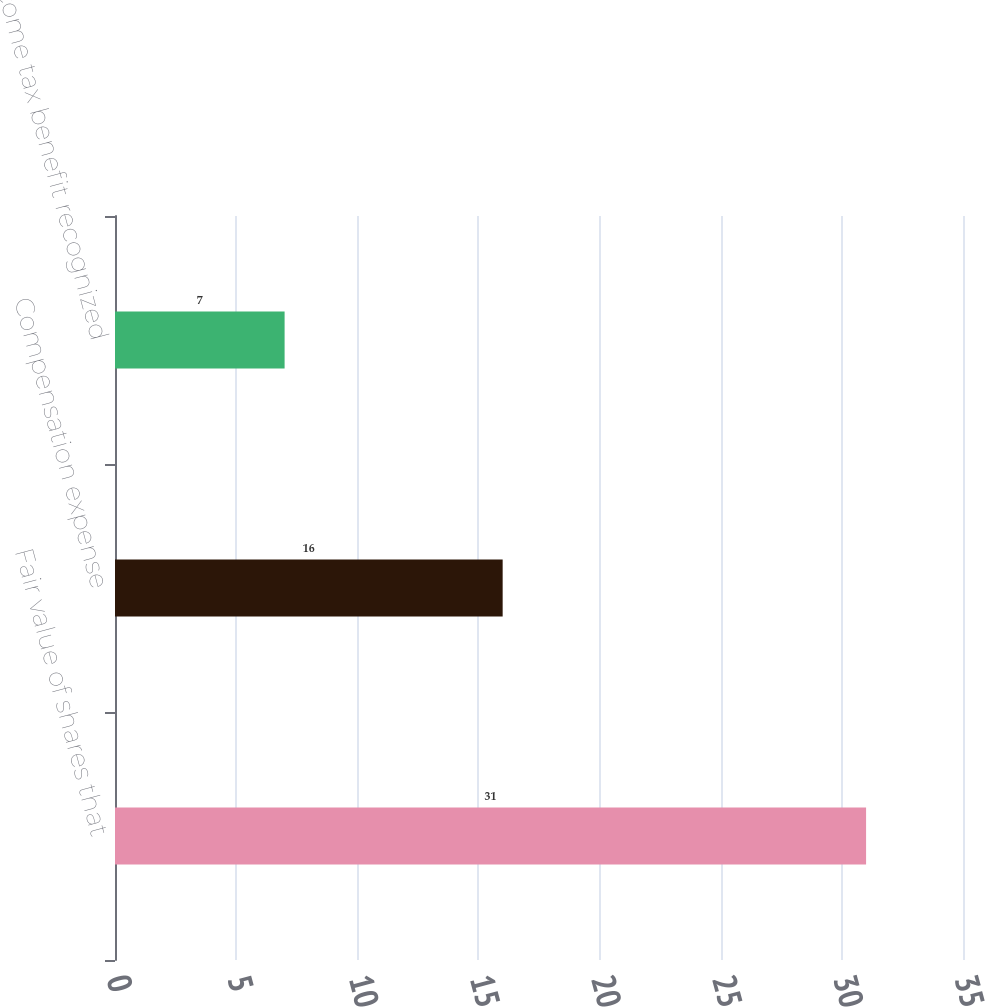<chart> <loc_0><loc_0><loc_500><loc_500><bar_chart><fcel>Fair value of shares that<fcel>Compensation expense<fcel>Income tax benefit recognized<nl><fcel>31<fcel>16<fcel>7<nl></chart> 